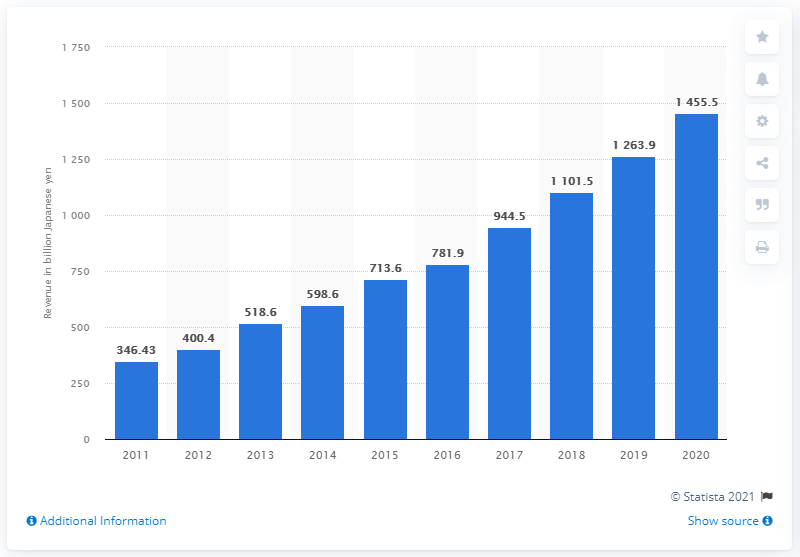Mention a couple of crucial points in this snapshot. Rakuten's previous yearly revenue in yen was 1263.9 million. In the fiscal year 2020, the annual revenue of the Rakuten Group was 1455.5 billion yen. 